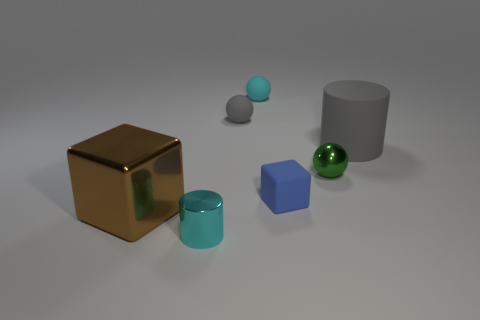Subtract all tiny cyan balls. How many balls are left? 2 Add 1 large metal cubes. How many objects exist? 8 Subtract 2 balls. How many balls are left? 1 Subtract all cylinders. How many objects are left? 5 Subtract all blue blocks. How many blocks are left? 1 Subtract all red spheres. Subtract all yellow cylinders. How many spheres are left? 3 Subtract all yellow cubes. How many blue cylinders are left? 0 Subtract all small blue blocks. Subtract all tiny gray rubber spheres. How many objects are left? 5 Add 5 large metallic cubes. How many large metallic cubes are left? 6 Add 2 big gray cylinders. How many big gray cylinders exist? 3 